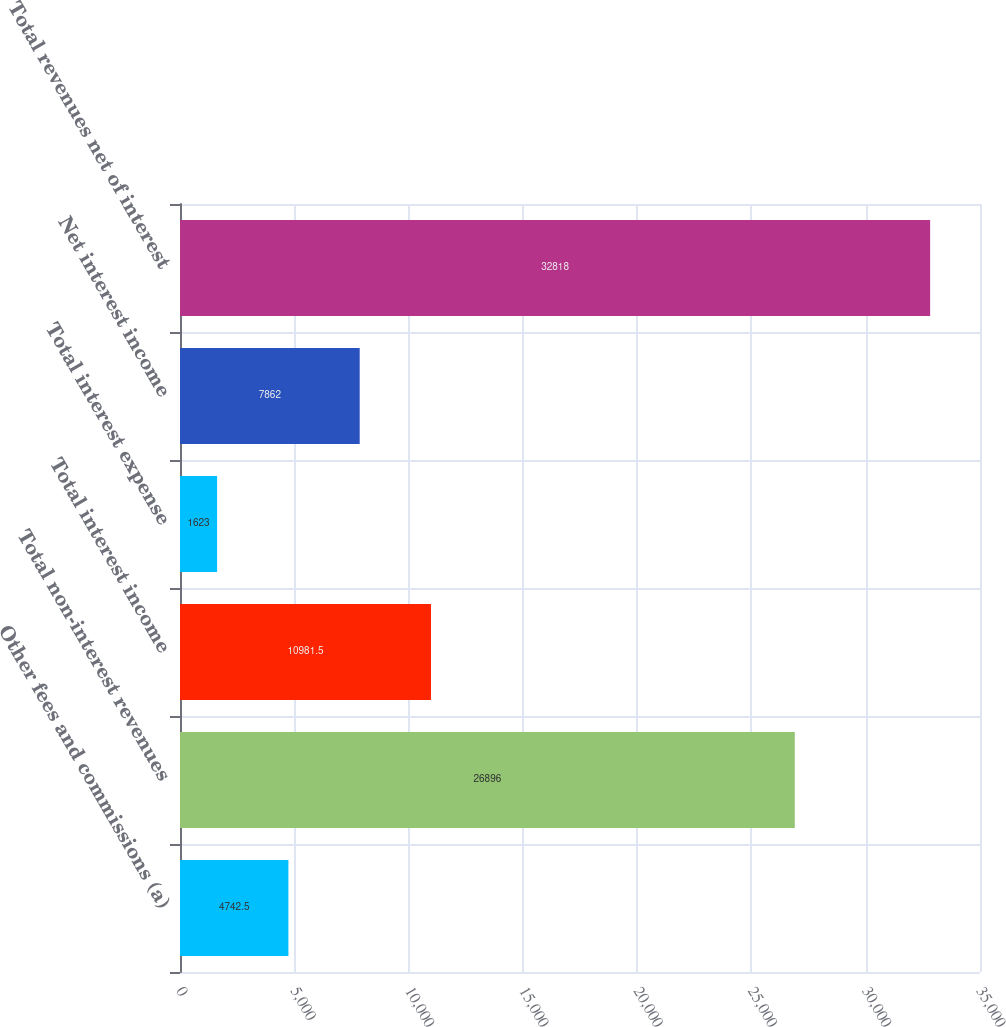<chart> <loc_0><loc_0><loc_500><loc_500><bar_chart><fcel>Other fees and commissions (a)<fcel>Total non-interest revenues<fcel>Total interest income<fcel>Total interest expense<fcel>Net interest income<fcel>Total revenues net of interest<nl><fcel>4742.5<fcel>26896<fcel>10981.5<fcel>1623<fcel>7862<fcel>32818<nl></chart> 